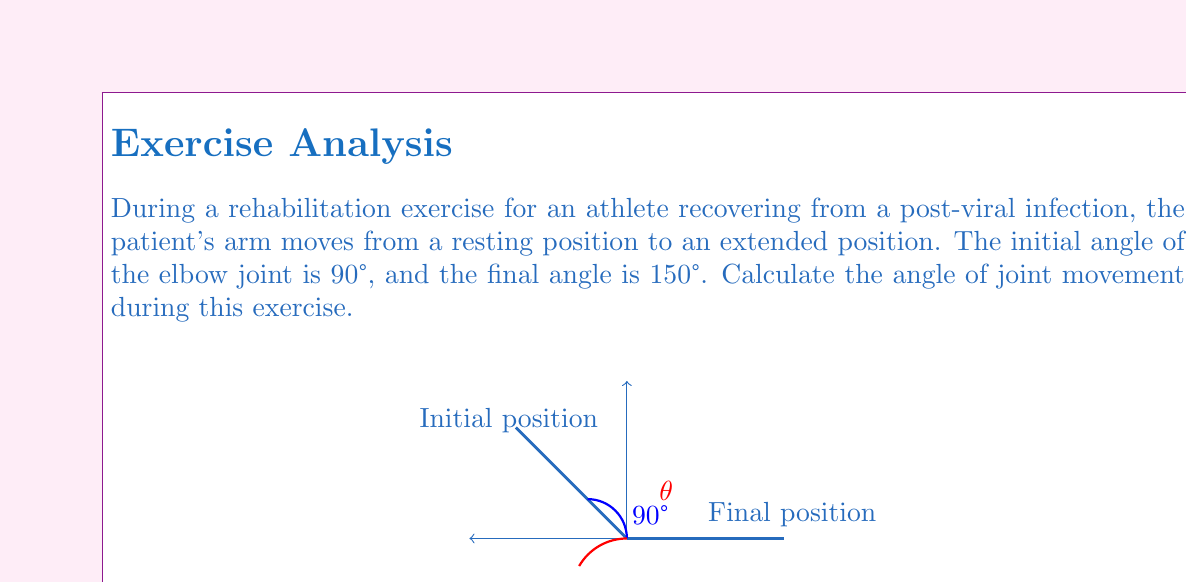Could you help me with this problem? To calculate the angle of joint movement, we need to find the difference between the final and initial angles of the elbow joint.

Step 1: Identify the given information
- Initial angle: 90°
- Final angle: 150°

Step 2: Set up the equation to calculate the angle of joint movement (θ)
$$ \theta = \text{Final angle} - \text{Initial angle} $$

Step 3: Substitute the given values into the equation
$$ \theta = 150° - 90° $$

Step 4: Perform the subtraction
$$ \theta = 60° $$

Therefore, the angle of joint movement during this rehabilitation exercise is 60°.
Answer: 60° 